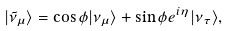<formula> <loc_0><loc_0><loc_500><loc_500>| \tilde { \nu } _ { \mu } \rangle = \cos \phi | \nu _ { \mu } \rangle + \sin \phi e ^ { i \eta } | \nu _ { \tau } \rangle ,</formula> 